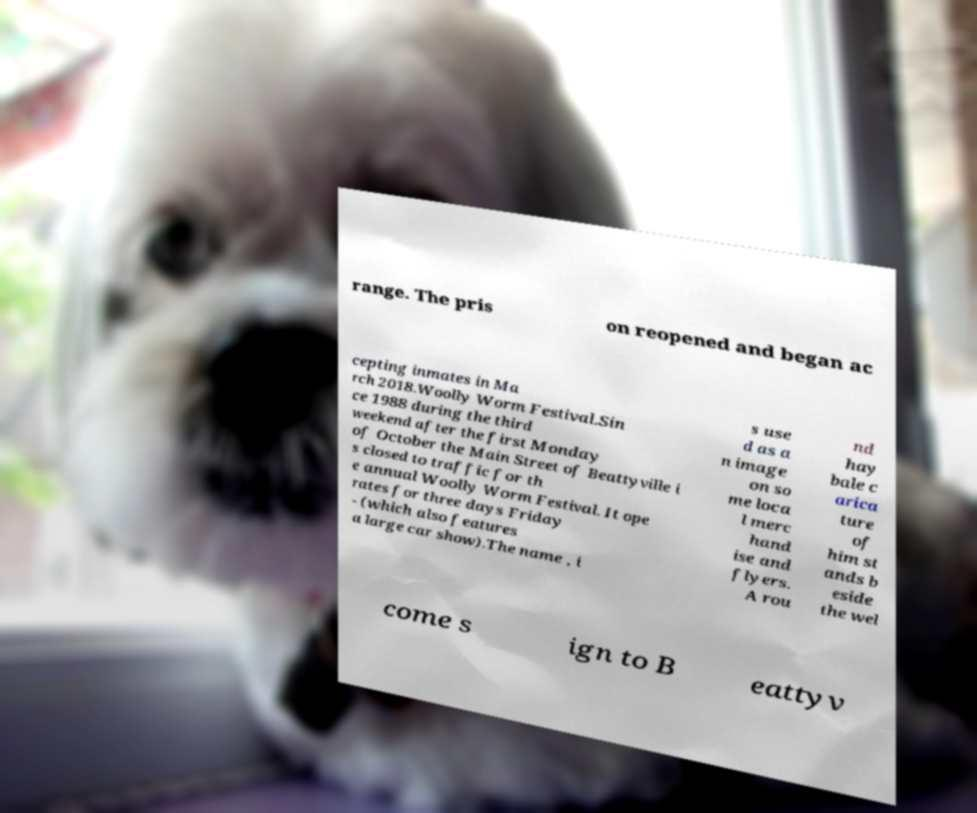What messages or text are displayed in this image? I need them in a readable, typed format. range. The pris on reopened and began ac cepting inmates in Ma rch 2018.Woolly Worm Festival.Sin ce 1988 during the third weekend after the first Monday of October the Main Street of Beattyville i s closed to traffic for th e annual Woolly Worm Festival. It ope rates for three days Friday - (which also features a large car show).The name , i s use d as a n image on so me loca l merc hand ise and flyers. A rou nd hay bale c arica ture of him st ands b eside the wel come s ign to B eattyv 